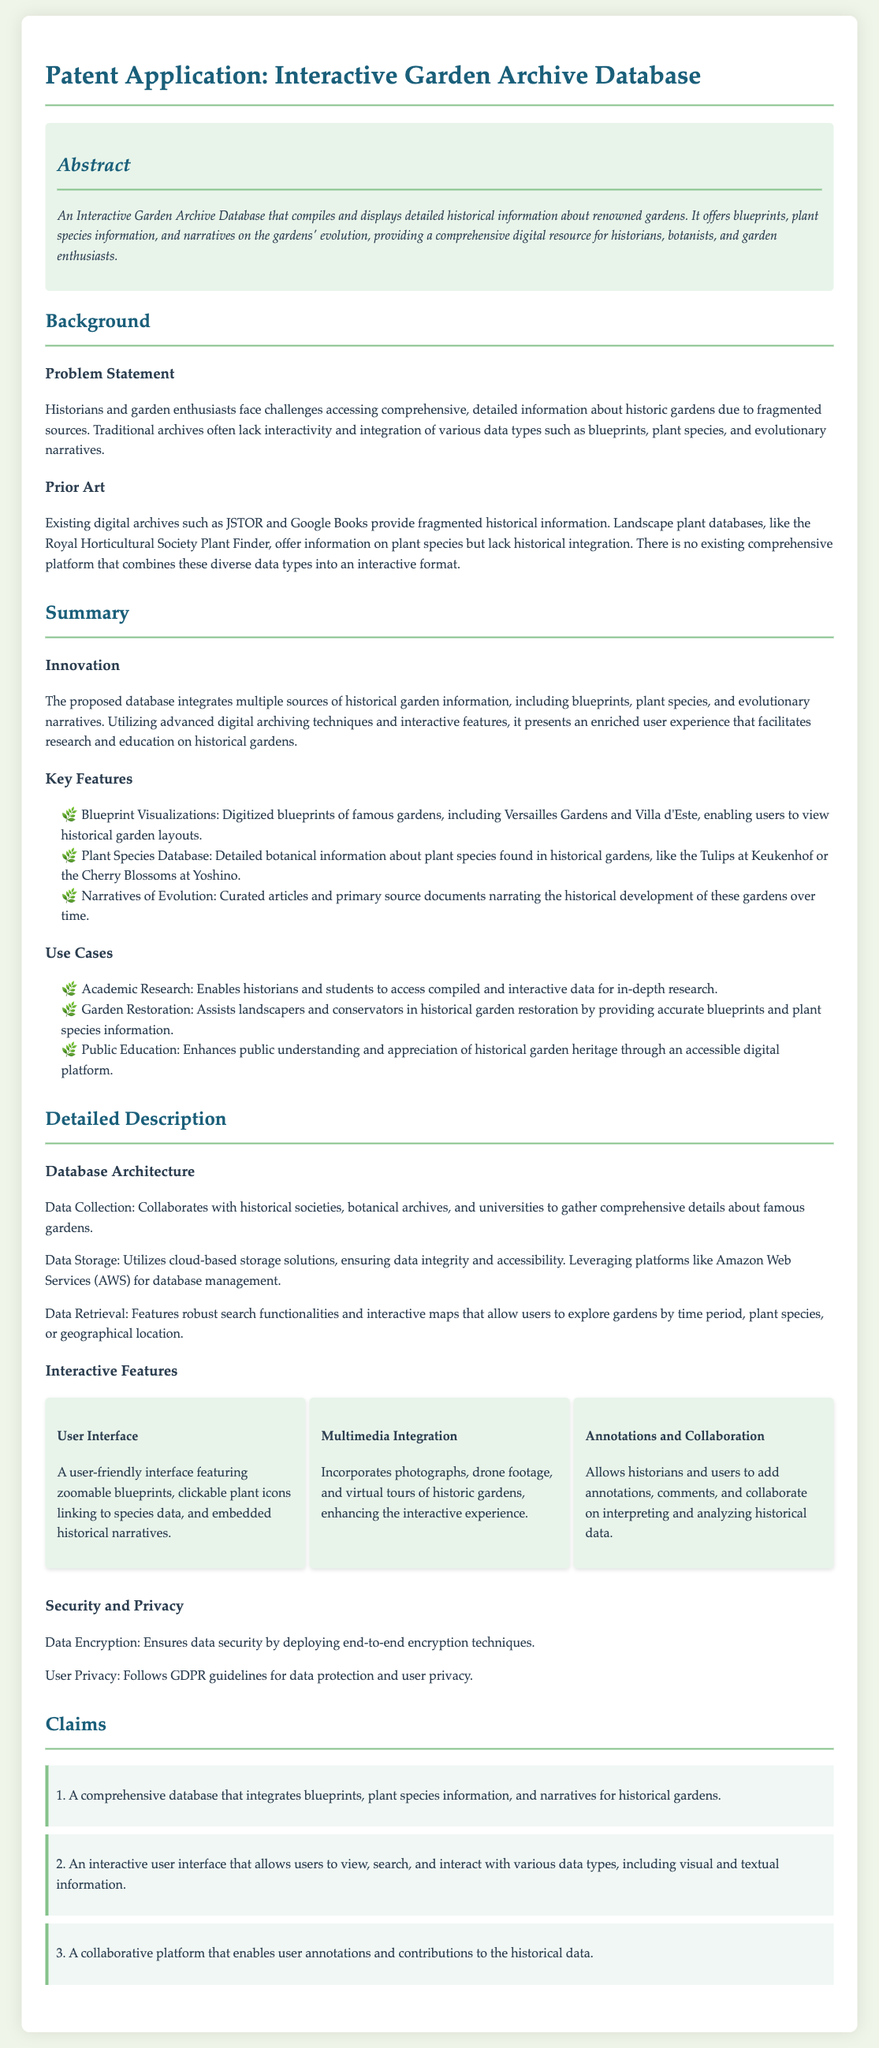What is the title of the patent application? The title is the heading of the document which identifies its subject matter.
Answer: Interactive Garden Archive Database What data types does the database integrate? The integration of blueprints, plant species information, and narratives is highlighted in the claims and summary.
Answer: Blueprints, plant species information, narratives What is the primary problem addressed by this database? The problem statement outlines the challenges historians and garden enthusiasts face, specifically regarding access.
Answer: Fragmented sources Which gardens are exemplified in the blueprint visualizations? The summary lists specific gardens as examples of where blueprints are provided, highlighting their historical significance.
Answer: Versailles Gardens, Villa d'Este How many key features are listed in the document? The number of key features can be tallied based on the items outlined in the summary section.
Answer: Three What is highlighted as a key use case for garden restoration? The document specifies how the database assists in historical restoration efforts.
Answer: Accurate blueprints What does the user interface enable users to do? The description of the user interface outlines its capabilities for interaction with the data provided in the database.
Answer: View, search, and interact Which guidelines are mentioned for user privacy? Security and privacy measures address data protection practices as part of the database's features.
Answer: GDPR What innovative aspect does the interactive database offer? The innovation outlines how the database updates the traditional archival methods with interactivity, aiding research.
Answer: Integration of multiple sources 